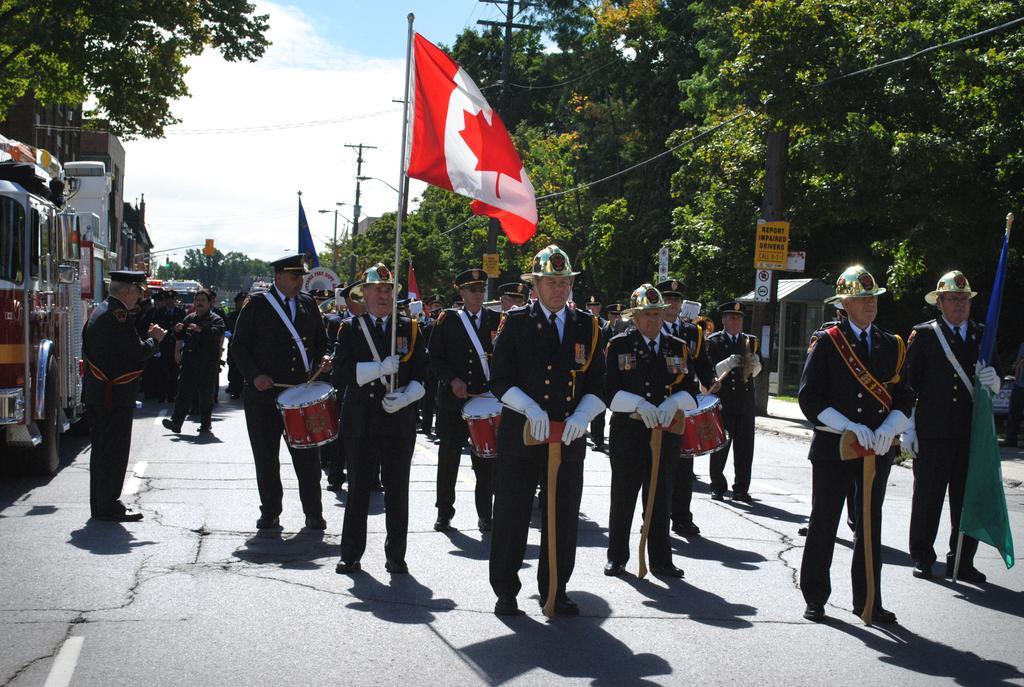Please provide a concise description of this image. In the middle of the image a group of people standing and holding something in their hands. Top left side of the image there is a tree and clouds. Bottom left side of the image there is a vehicle. Top right side of the image There is a tree and pole. 